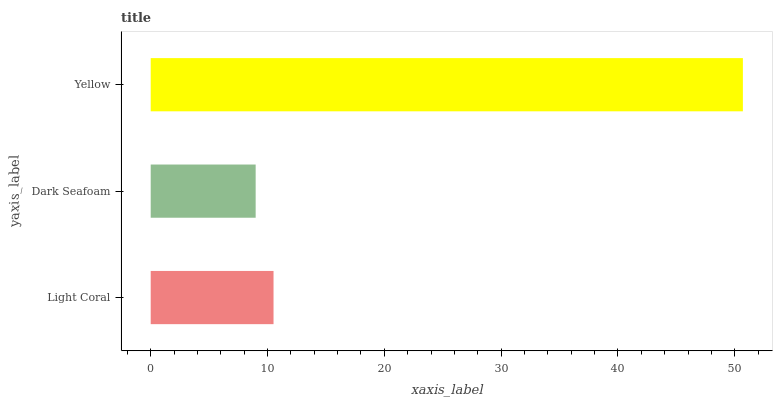Is Dark Seafoam the minimum?
Answer yes or no. Yes. Is Yellow the maximum?
Answer yes or no. Yes. Is Yellow the minimum?
Answer yes or no. No. Is Dark Seafoam the maximum?
Answer yes or no. No. Is Yellow greater than Dark Seafoam?
Answer yes or no. Yes. Is Dark Seafoam less than Yellow?
Answer yes or no. Yes. Is Dark Seafoam greater than Yellow?
Answer yes or no. No. Is Yellow less than Dark Seafoam?
Answer yes or no. No. Is Light Coral the high median?
Answer yes or no. Yes. Is Light Coral the low median?
Answer yes or no. Yes. Is Yellow the high median?
Answer yes or no. No. Is Yellow the low median?
Answer yes or no. No. 